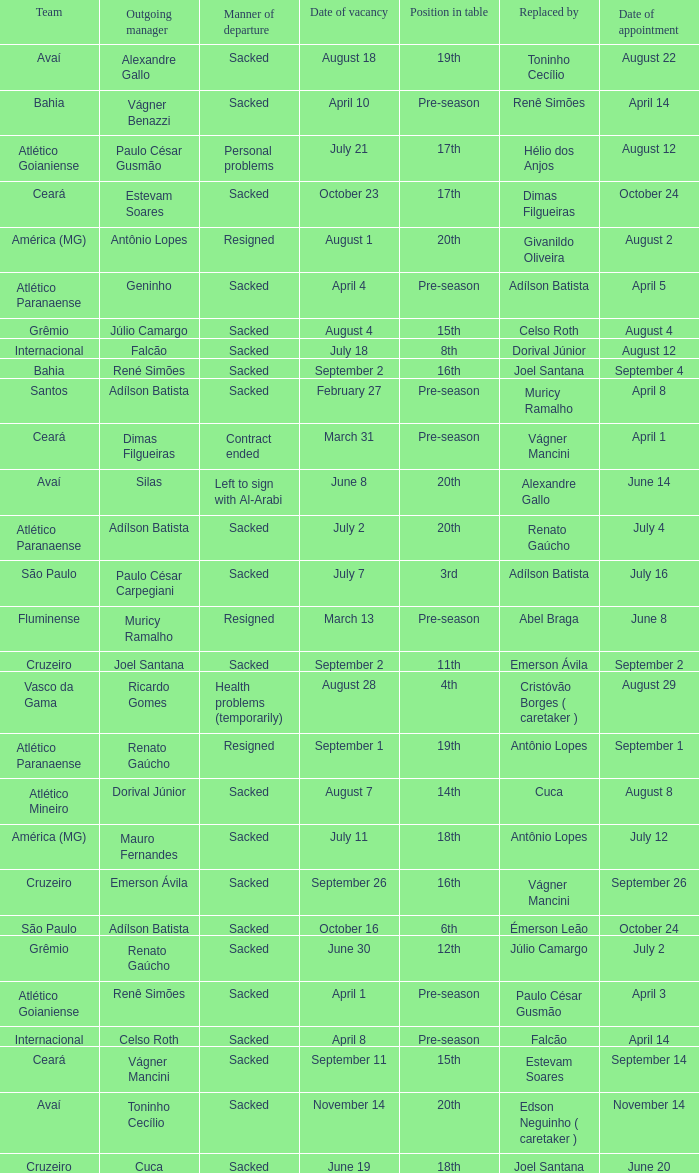How many times did Silas leave as a team manager? 1.0. Can you parse all the data within this table? {'header': ['Team', 'Outgoing manager', 'Manner of departure', 'Date of vacancy', 'Position in table', 'Replaced by', 'Date of appointment'], 'rows': [['Avaí', 'Alexandre Gallo', 'Sacked', 'August 18', '19th', 'Toninho Cecílio', 'August 22'], ['Bahia', 'Vágner Benazzi', 'Sacked', 'April 10', 'Pre-season', 'Renê Simões', 'April 14'], ['Atlético Goianiense', 'Paulo César Gusmão', 'Personal problems', 'July 21', '17th', 'Hélio dos Anjos', 'August 12'], ['Ceará', 'Estevam Soares', 'Sacked', 'October 23', '17th', 'Dimas Filgueiras', 'October 24'], ['América (MG)', 'Antônio Lopes', 'Resigned', 'August 1', '20th', 'Givanildo Oliveira', 'August 2'], ['Atlético Paranaense', 'Geninho', 'Sacked', 'April 4', 'Pre-season', 'Adílson Batista', 'April 5'], ['Grêmio', 'Júlio Camargo', 'Sacked', 'August 4', '15th', 'Celso Roth', 'August 4'], ['Internacional', 'Falcão', 'Sacked', 'July 18', '8th', 'Dorival Júnior', 'August 12'], ['Bahia', 'René Simões', 'Sacked', 'September 2', '16th', 'Joel Santana', 'September 4'], ['Santos', 'Adílson Batista', 'Sacked', 'February 27', 'Pre-season', 'Muricy Ramalho', 'April 8'], ['Ceará', 'Dimas Filgueiras', 'Contract ended', 'March 31', 'Pre-season', 'Vágner Mancini', 'April 1'], ['Avaí', 'Silas', 'Left to sign with Al-Arabi', 'June 8', '20th', 'Alexandre Gallo', 'June 14'], ['Atlético Paranaense', 'Adílson Batista', 'Sacked', 'July 2', '20th', 'Renato Gaúcho', 'July 4'], ['São Paulo', 'Paulo César Carpegiani', 'Sacked', 'July 7', '3rd', 'Adílson Batista', 'July 16'], ['Fluminense', 'Muricy Ramalho', 'Resigned', 'March 13', 'Pre-season', 'Abel Braga', 'June 8'], ['Cruzeiro', 'Joel Santana', 'Sacked', 'September 2', '11th', 'Emerson Ávila', 'September 2'], ['Vasco da Gama', 'Ricardo Gomes', 'Health problems (temporarily)', 'August 28', '4th', 'Cristóvão Borges ( caretaker )', 'August 29'], ['Atlético Paranaense', 'Renato Gaúcho', 'Resigned', 'September 1', '19th', 'Antônio Lopes', 'September 1'], ['Atlético Mineiro', 'Dorival Júnior', 'Sacked', 'August 7', '14th', 'Cuca', 'August 8'], ['América (MG)', 'Mauro Fernandes', 'Sacked', 'July 11', '18th', 'Antônio Lopes', 'July 12'], ['Cruzeiro', 'Emerson Ávila', 'Sacked', 'September 26', '16th', 'Vágner Mancini', 'September 26'], ['São Paulo', 'Adílson Batista', 'Sacked', 'October 16', '6th', 'Émerson Leão', 'October 24'], ['Grêmio', 'Renato Gaúcho', 'Sacked', 'June 30', '12th', 'Júlio Camargo', 'July 2'], ['Atlético Goianiense', 'Renê Simões', 'Sacked', 'April 1', 'Pre-season', 'Paulo César Gusmão', 'April 3'], ['Internacional', 'Celso Roth', 'Sacked', 'April 8', 'Pre-season', 'Falcão', 'April 14'], ['Ceará', 'Vágner Mancini', 'Sacked', 'September 11', '15th', 'Estevam Soares', 'September 14'], ['Avaí', 'Toninho Cecílio', 'Sacked', 'November 14', '20th', 'Edson Neguinho ( caretaker )', 'November 14'], ['Cruzeiro', 'Cuca', 'Sacked', 'June 19', '18th', 'Joel Santana', 'June 20']]} 